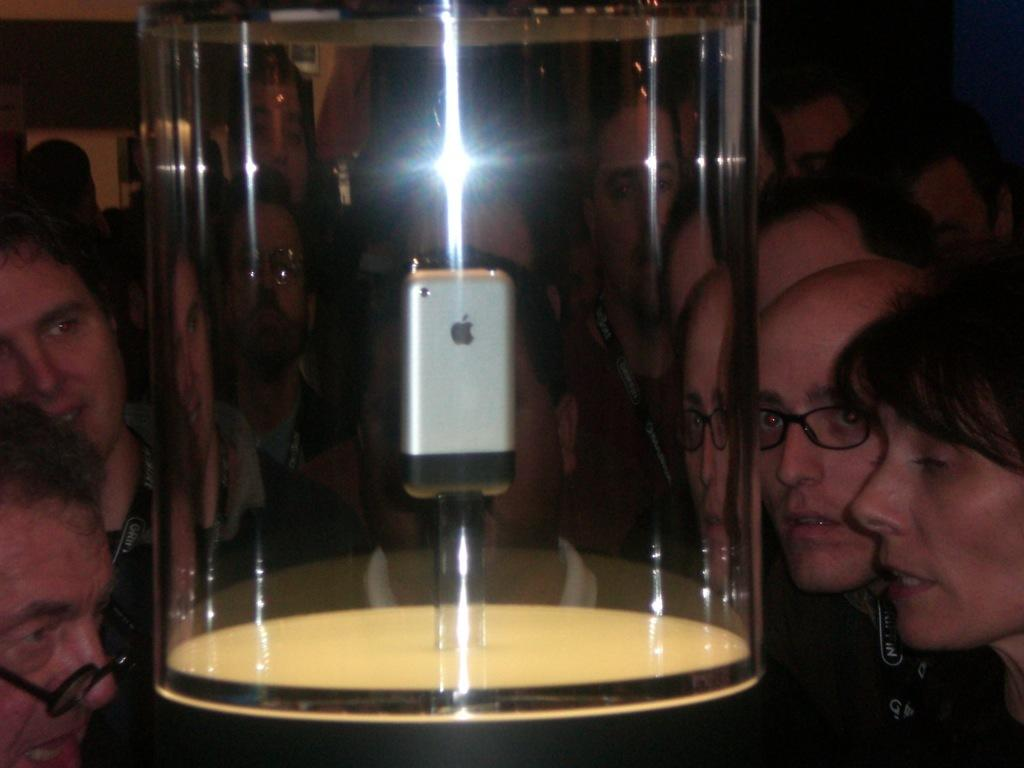What type of phone is in the glass box in the image? There is an Apple phone in a glass box in the image. Can you describe the people around the glass box? There are people around the glass box in the image. What is the object in the image? The object in the image is the glass box containing the Apple phone. What type of window treatment is present in the image? There are curtains attached to the wall in the image. What type of root can be seen growing from the Apple phone in the image? There is no root growing from the Apple phone in the image; it is an electronic device inside a glass box. 